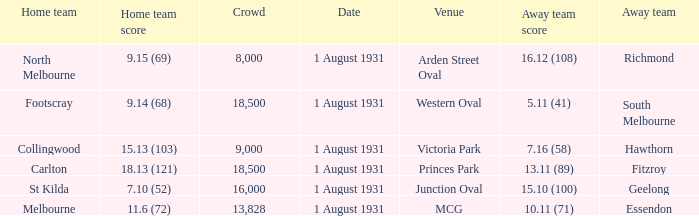What is the home team at the venue mcg? Melbourne. 